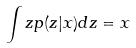Convert formula to latex. <formula><loc_0><loc_0><loc_500><loc_500>\int z p ( z | x ) d z = x</formula> 